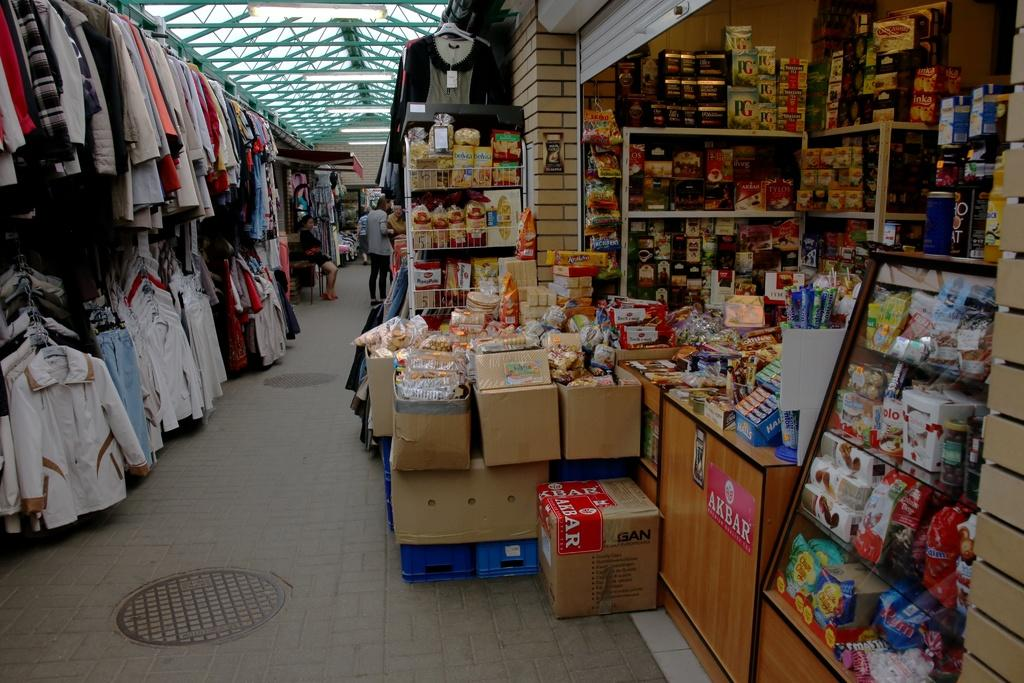Provide a one-sentence caption for the provided image. An Akbar sticker is on a box and below the counter of a store that sells clothing and other items. 